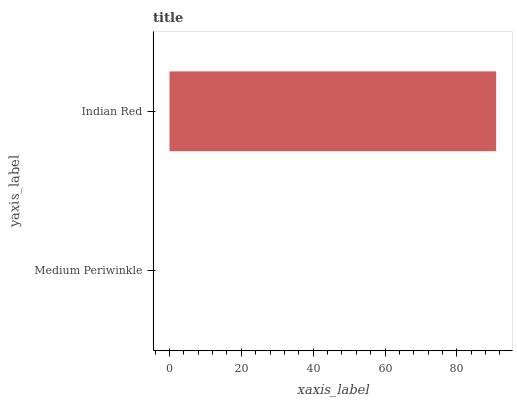Is Medium Periwinkle the minimum?
Answer yes or no. Yes. Is Indian Red the maximum?
Answer yes or no. Yes. Is Indian Red the minimum?
Answer yes or no. No. Is Indian Red greater than Medium Periwinkle?
Answer yes or no. Yes. Is Medium Periwinkle less than Indian Red?
Answer yes or no. Yes. Is Medium Periwinkle greater than Indian Red?
Answer yes or no. No. Is Indian Red less than Medium Periwinkle?
Answer yes or no. No. Is Indian Red the high median?
Answer yes or no. Yes. Is Medium Periwinkle the low median?
Answer yes or no. Yes. Is Medium Periwinkle the high median?
Answer yes or no. No. Is Indian Red the low median?
Answer yes or no. No. 